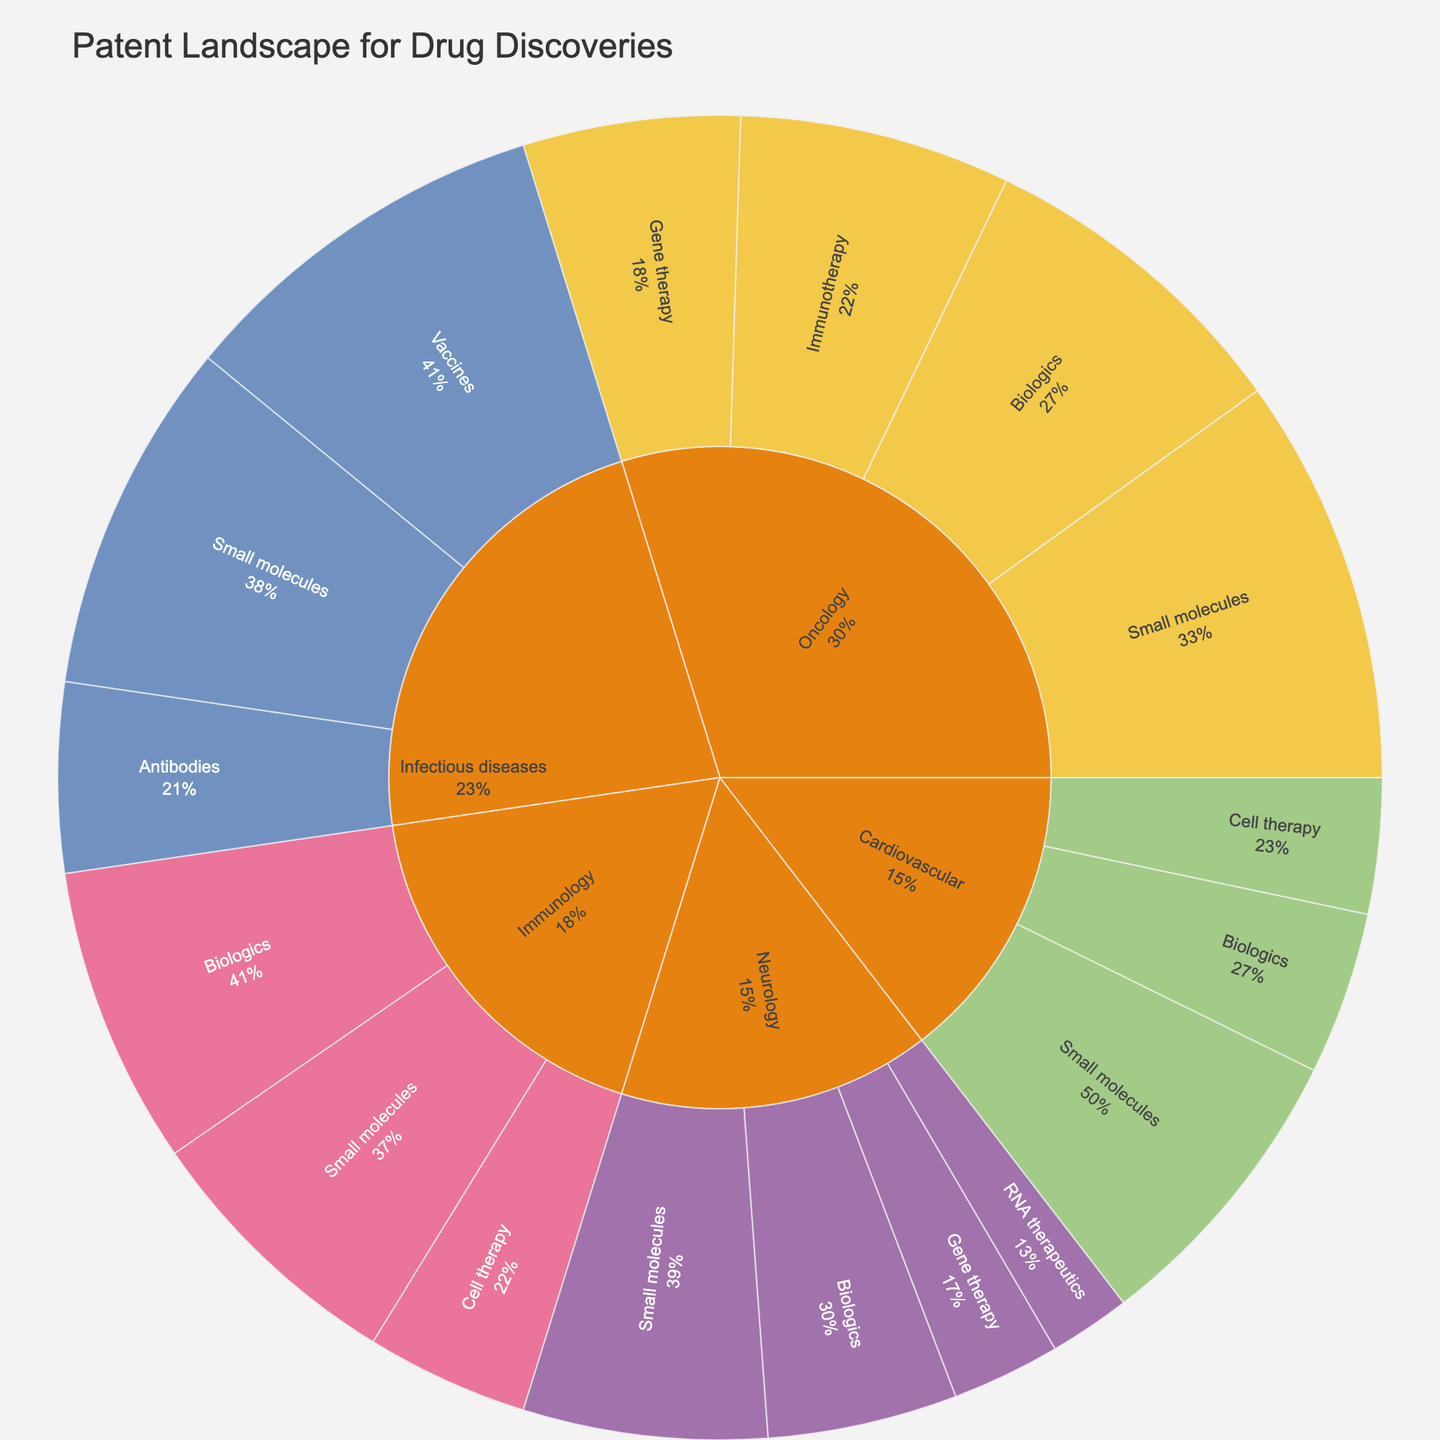What is the title of the Sunburst Plot? The title of the plot is located at the top and provides an overall description of the data being visualized. By observing the plot, we can see this text.
Answer: Patent Landscape for Drug Discoveries Which therapeutic area has the most patents for Small molecules? By analyzing the branches under each therapeutic area, we can sum the value of patents for Small molecules and compare them. Oncology has 150, Neurology has 90, Cardiovascular has 110, Infectious diseases have 130, and Immunology has 100.
Answer: Oncology How many patents does Immunology have in total? To find the total number of patents in Immunology, add the values of all branches under Immunology: Small molecules (100), Biologics (110), and Cell therapy (60). 100 + 110 + 60 = 270.
Answer: 270 Which technology platform has the smallest number of patents in the Neurology therapeutic area? By comparing the values under Neurology, we see that RNA therapeutics has the smallest number of patents: Small molecules (90), Biologics (70), Gene therapy (40), RNA therapeutics (30).
Answer: RNA therapeutics What is the percentage of patents in Vaccines within the Infectious diseases therapeutic area? To find this percentage, divide the number of Vaccines patents by the total number of Infectious diseases patents: (140 / (130 + 140 + 70)). First, find the total: 130 + 140 + 70 = 340. Then, 140 / 340 ≈ 0.411. Converting to a percentage: 0.411 × 100 ≈ 41.1%.
Answer: 41.1% Compare the total number of patents for Biologics across all therapeutic areas. Which one has the highest value, and what is it? Add the Biologics patents for each therapeutic area: Oncology (120), Neurology (70), Cardiovascular (60), Infectious diseases (0), Immunology (110). Oncology (120) has the highest number.
Answer: Oncology, 120 What is the combined number of patents for Cell therapy in Cardiovascular and Immunology? Add the values for Cell therapy under both therapeutic areas: Cardiovascular (50) + Immunology (60). 50 + 60 = 110.
Answer: 110 Which therapeutic area has the fewest total patents, and what are they? Sum the values for each therapeutic area and compare: Oncology (450), Neurology (230), Cardiovascular (220), Infectious diseases (340), Immunology (270). Cardiovascular has the fewest with 220.
Answer: Cardiovascular, 220 What proportion of Oncology patents are for Gene therapy compared to the total Oncology patents? Divide the Gene therapy patents by the total Oncology patents: (80 / (150 + 120 + 80 + 100)). First, find the total: 150 + 120 + 80 + 100 = 450. Then, 80 / 450 ≈ 0.178. Converting to a percentage: 0.178 × 100 ≈ 17.8%.
Answer: 17.8% What is the difference in the number of patents for Small molecules between Oncology and Neurology? Subtract the Small molecules patents in Neurology from those in Oncology: 150 (Oncology) - 90 (Neurology). 150 - 90 = 60.
Answer: 60 